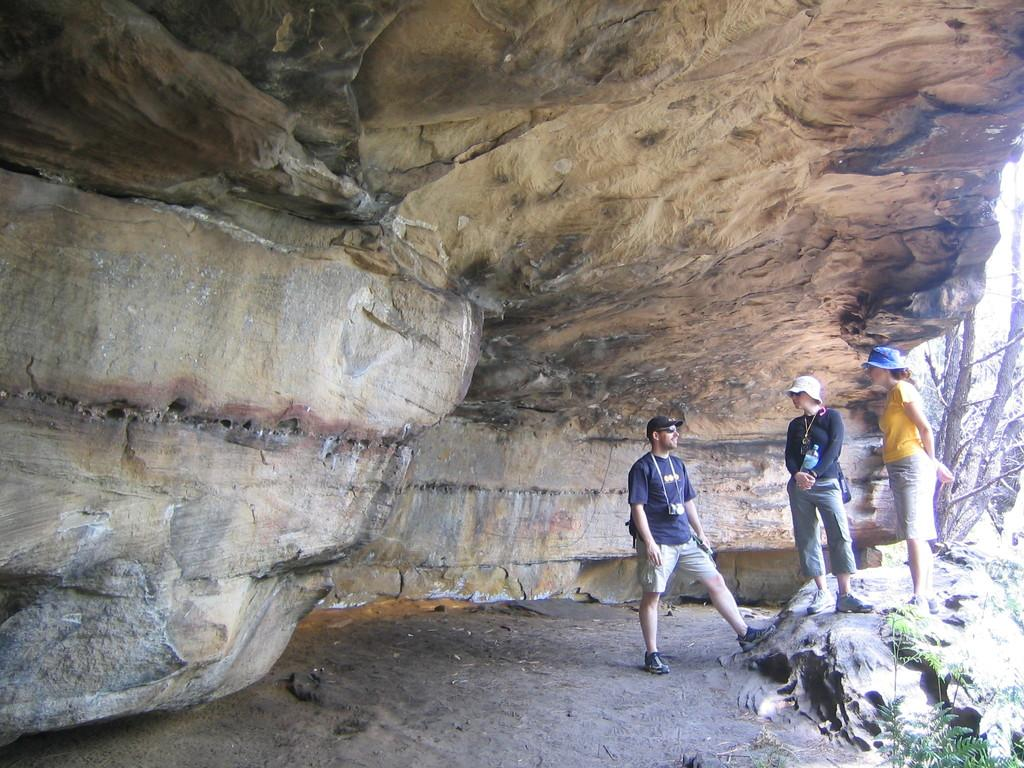Who or what can be seen in the image? There are people in the image. Where are the people located in the image? The people are under a rock surface. What type of natural elements can be seen in the image? Branches and leaves are visible in the image. What type of activity are the planes performing in the image? There are no planes present in the image, so it is not possible to answer that question. 